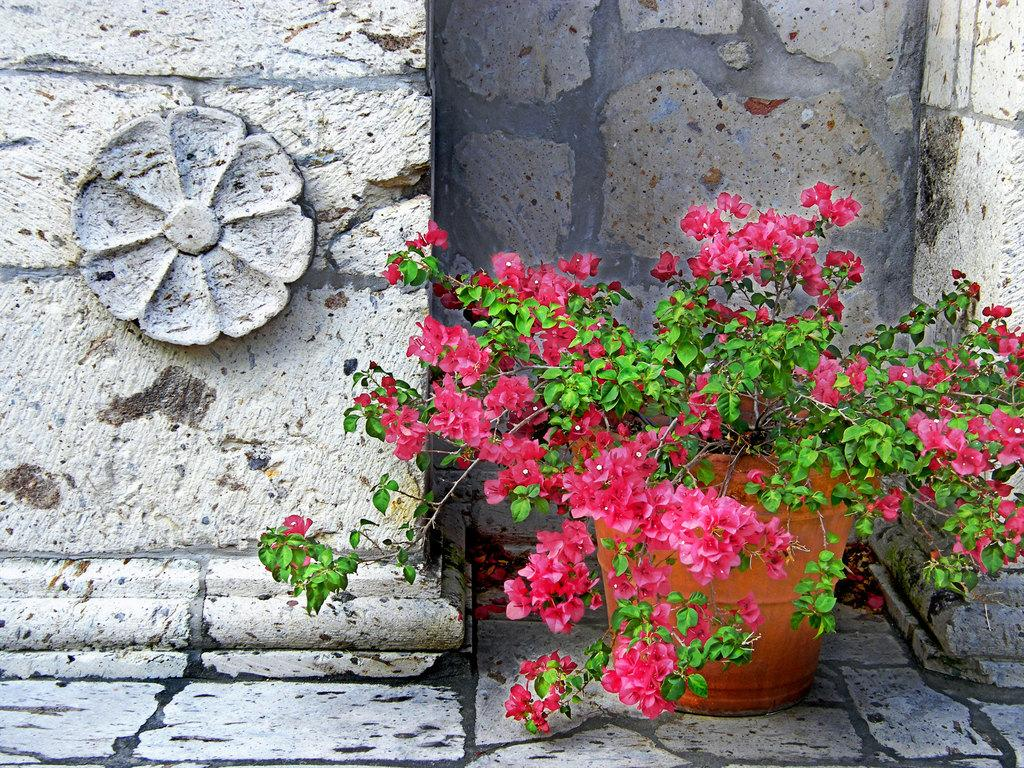What type of flowers can be seen in the image? There are pink color flowers in the image. What do the flowers belong to? The flowers belong to a plant. Where is the plant located? There is a flower pot in the image, which suggests that the plant is in the pot. What can be seen in the background of the image? There is a flower design on a stone wall in the background. Can you see the flowers playing on the sidewalk in the image? No, there are no flowers playing on the sidewalk in the image. The flowers are part of a plant in a flower pot, and there is no mention of a sidewalk in the provided facts. 